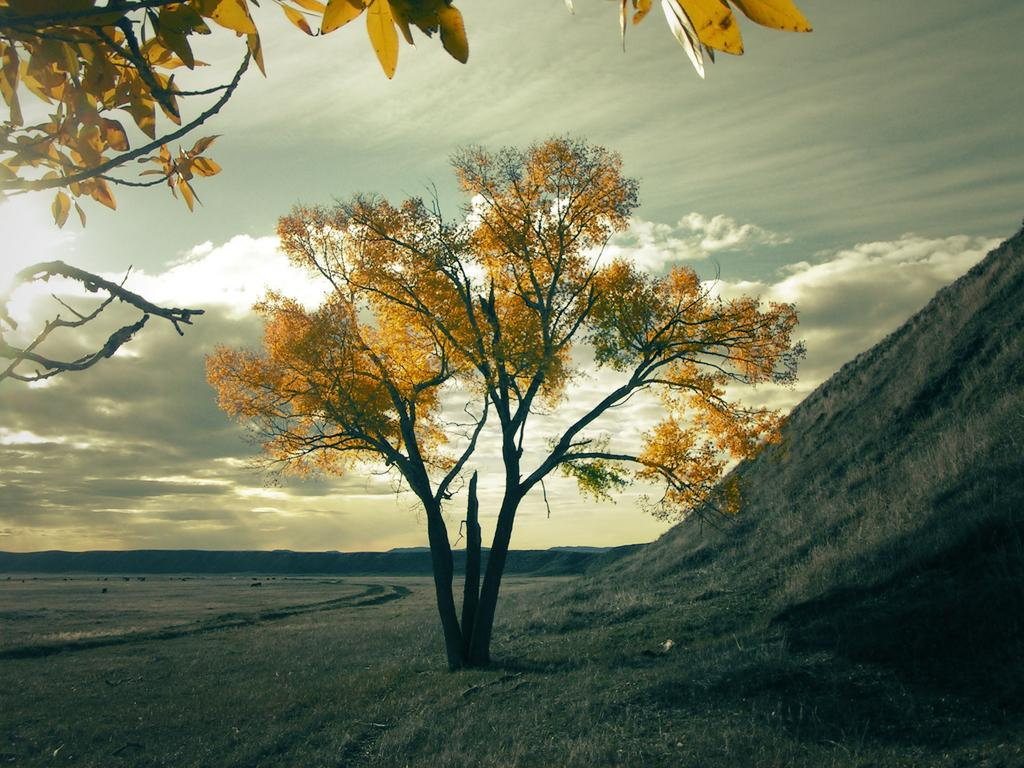What type of landscape is depicted in the image? There is a land in the image. What natural element can be seen on the land? There is a tree in the image. What is visible above the land in the image? The sky is visible in the image. What can be observed in the sky? Clouds are present in the sky. How many letters are being worked on by the tree in the image? There are no letters or any indication of work being done by the tree in the image. 